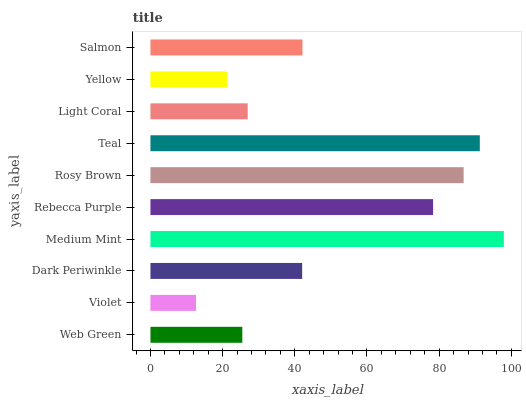Is Violet the minimum?
Answer yes or no. Yes. Is Medium Mint the maximum?
Answer yes or no. Yes. Is Dark Periwinkle the minimum?
Answer yes or no. No. Is Dark Periwinkle the maximum?
Answer yes or no. No. Is Dark Periwinkle greater than Violet?
Answer yes or no. Yes. Is Violet less than Dark Periwinkle?
Answer yes or no. Yes. Is Violet greater than Dark Periwinkle?
Answer yes or no. No. Is Dark Periwinkle less than Violet?
Answer yes or no. No. Is Salmon the high median?
Answer yes or no. Yes. Is Dark Periwinkle the low median?
Answer yes or no. Yes. Is Medium Mint the high median?
Answer yes or no. No. Is Rosy Brown the low median?
Answer yes or no. No. 